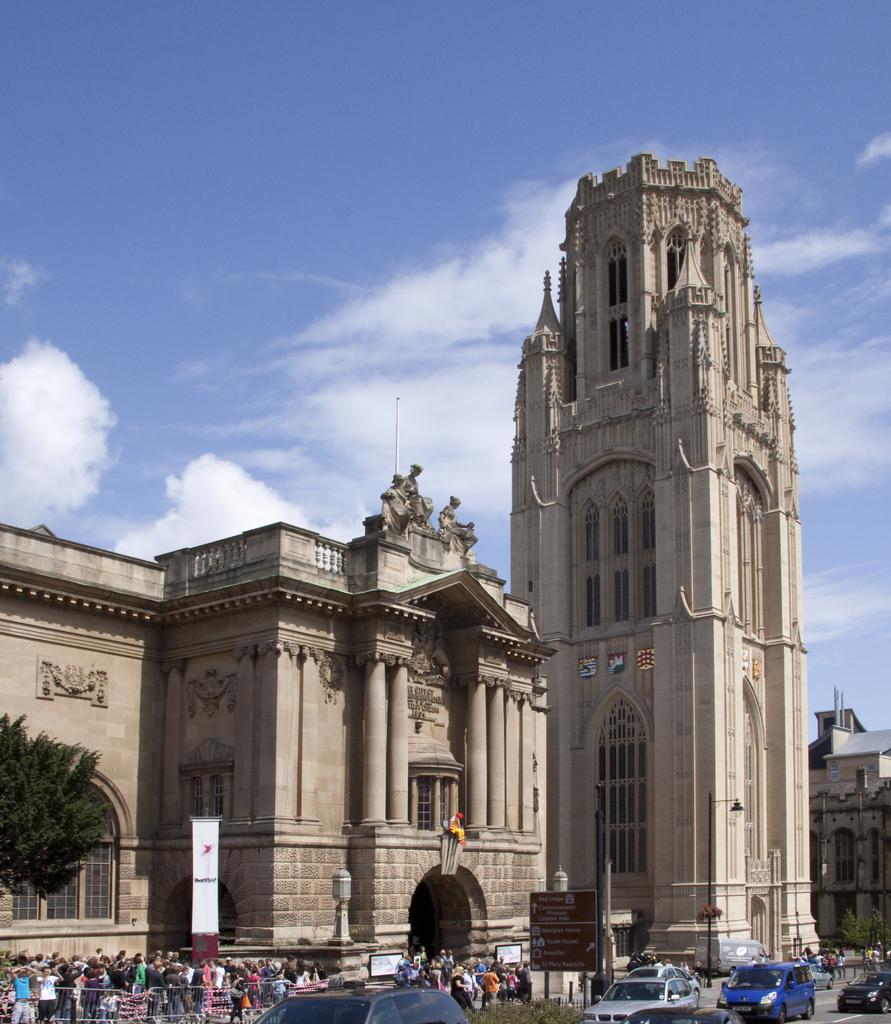What types of structures can be seen in the image? There are buildings in the image. What other objects are present in the image? There are statues, street poles, and street lights in the image. What is happening on the road in the image? There are persons walking and motor vehicles on the road in the image. What can be seen in the background of the image? The sky is visible in the background of the image, with clouds present. What type of vegetation is visible in the image? There are trees in the image. How many quivers can be seen hanging from the street poles in the image? There are no quivers present in the image; it features buildings, statues, persons walking, motor vehicles, street poles, street lights, trees, and a sky with clouds. What type of lamp is attached to the trees in the image? There are no lamps attached to the trees in the image; it only features street lights. 